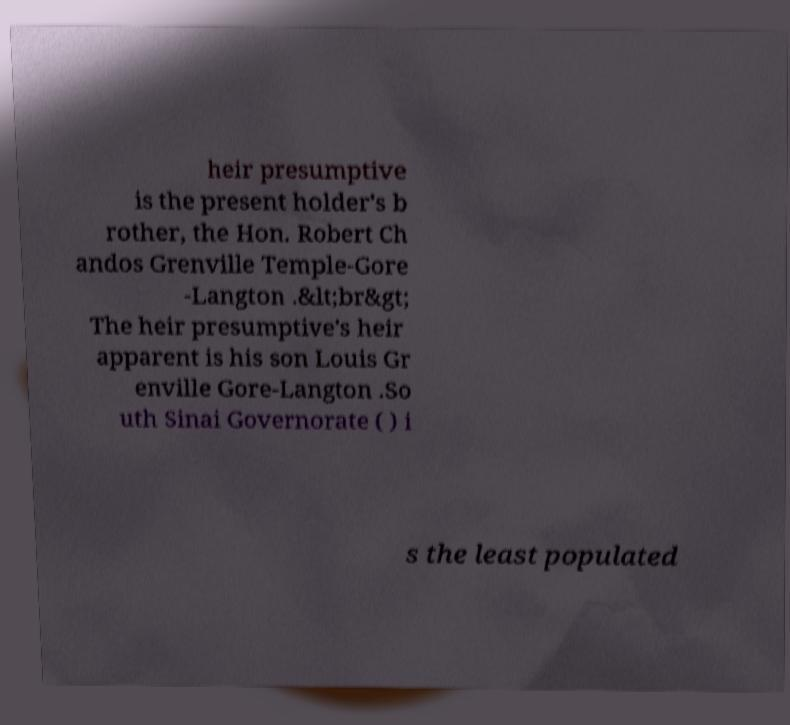Could you assist in decoding the text presented in this image and type it out clearly? heir presumptive is the present holder's b rother, the Hon. Robert Ch andos Grenville Temple-Gore -Langton .&lt;br&gt; The heir presumptive's heir apparent is his son Louis Gr enville Gore-Langton .So uth Sinai Governorate ( ) i s the least populated 